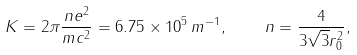<formula> <loc_0><loc_0><loc_500><loc_500>K = 2 \pi \frac { n e ^ { 2 } } { m c ^ { 2 } } = 6 . 7 5 \times 1 0 ^ { 5 } \, m ^ { - 1 } , \quad n = \frac { 4 } { 3 \sqrt { 3 } r _ { 0 } ^ { 2 } } ,</formula> 